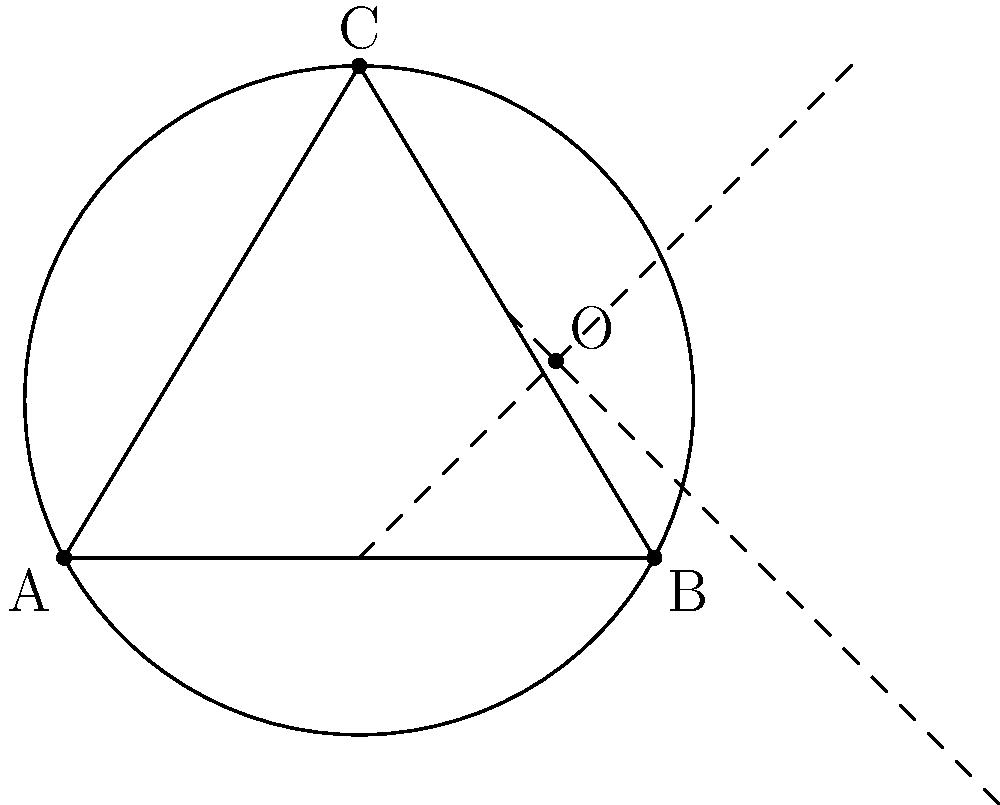In a scene from "The Da Vinci Code", Robert Langdon discovers a hidden message on a painting that leads to three points forming a perfect circle. Given the coordinates of these three points: A(0,0), B(6,0), and C(3,5), what are the coordinates of the center of this circle? Round your answer to two decimal places. To find the center of a circle given three points on its circumference, we can follow these steps:

1) The center of the circle lies on the perpendicular bisector of any chord of the circle. We'll use two chords: AB and BC.

2) For chord AB:
   Midpoint M1 = $(\frac{0+6}{2}, \frac{0+0}{2}) = (3,0)$

3) For chord BC:
   Midpoint M2 = $(\frac{6+3}{2}, \frac{0+5}{2}) = (4.5, 2.5)$

4) The perpendicular bisector of AB passes through (3,0) and is perpendicular to AB. Its equation is:
   $x = 3$

5) The perpendicular bisector of BC has a slope perpendicular to BC's slope:
   Slope of BC = $\frac{5-0}{3-6} = -\frac{5}{3}$
   Perpendicular slope = $\frac{3}{5}$

   Using point-slope form with M2(4.5, 2.5):
   $y - 2.5 = \frac{3}{5}(x - 4.5)$

6) The center is at the intersection of these two lines. Substituting $x=3$ into the second equation:
   $y - 2.5 = \frac{3}{5}(3 - 4.5) = -\frac{9}{10}$
   $y = 2.5 - \frac{9}{10} = 1.6$

Therefore, the center is at (3, 1.6).
Answer: (3.00, 1.60) 